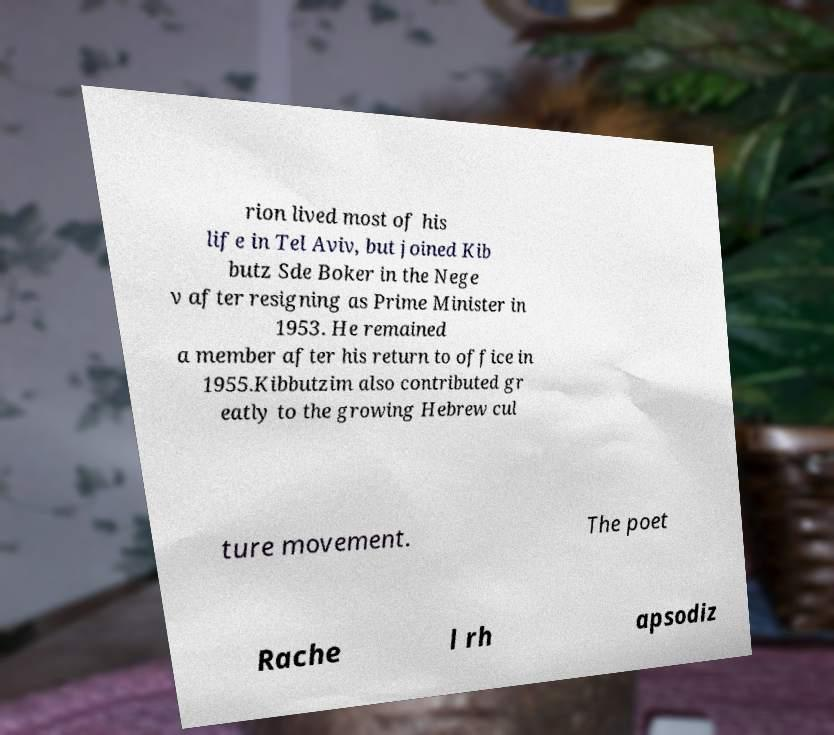Could you assist in decoding the text presented in this image and type it out clearly? rion lived most of his life in Tel Aviv, but joined Kib butz Sde Boker in the Nege v after resigning as Prime Minister in 1953. He remained a member after his return to office in 1955.Kibbutzim also contributed gr eatly to the growing Hebrew cul ture movement. The poet Rache l rh apsodiz 